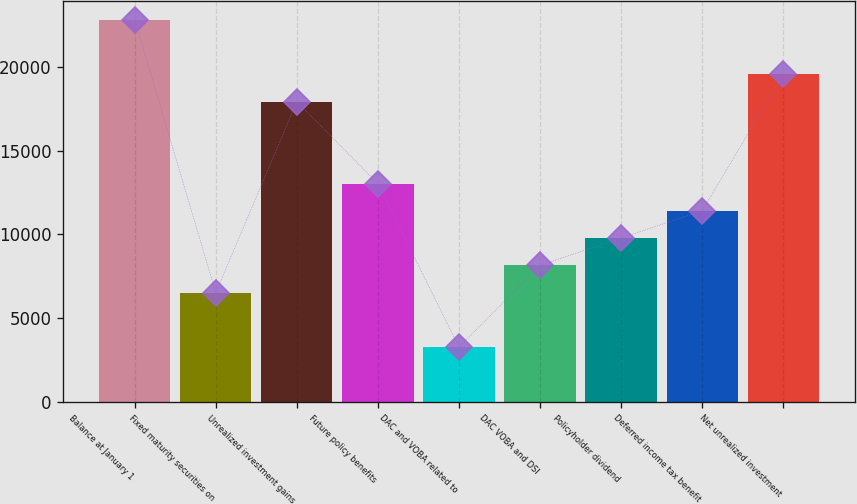Convert chart to OTSL. <chart><loc_0><loc_0><loc_500><loc_500><bar_chart><fcel>Balance at January 1<fcel>Fixed maturity securities on<fcel>Unrealized investment gains<fcel>Future policy benefits<fcel>DAC and VOBA related to<fcel>DAC VOBA and DSI<fcel>Policyholder dividend<fcel>Deferred income tax benefit<fcel>Net unrealized investment<nl><fcel>22819.2<fcel>6521.2<fcel>17929.8<fcel>13040.4<fcel>3261.6<fcel>8151<fcel>9780.8<fcel>11410.6<fcel>19559.6<nl></chart> 